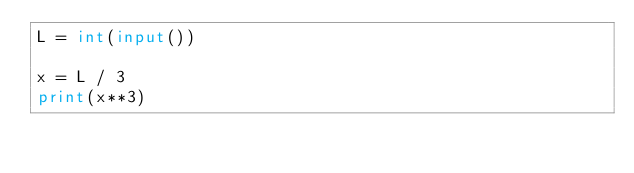<code> <loc_0><loc_0><loc_500><loc_500><_Python_>L = int(input())

x = L / 3
print(x**3)</code> 